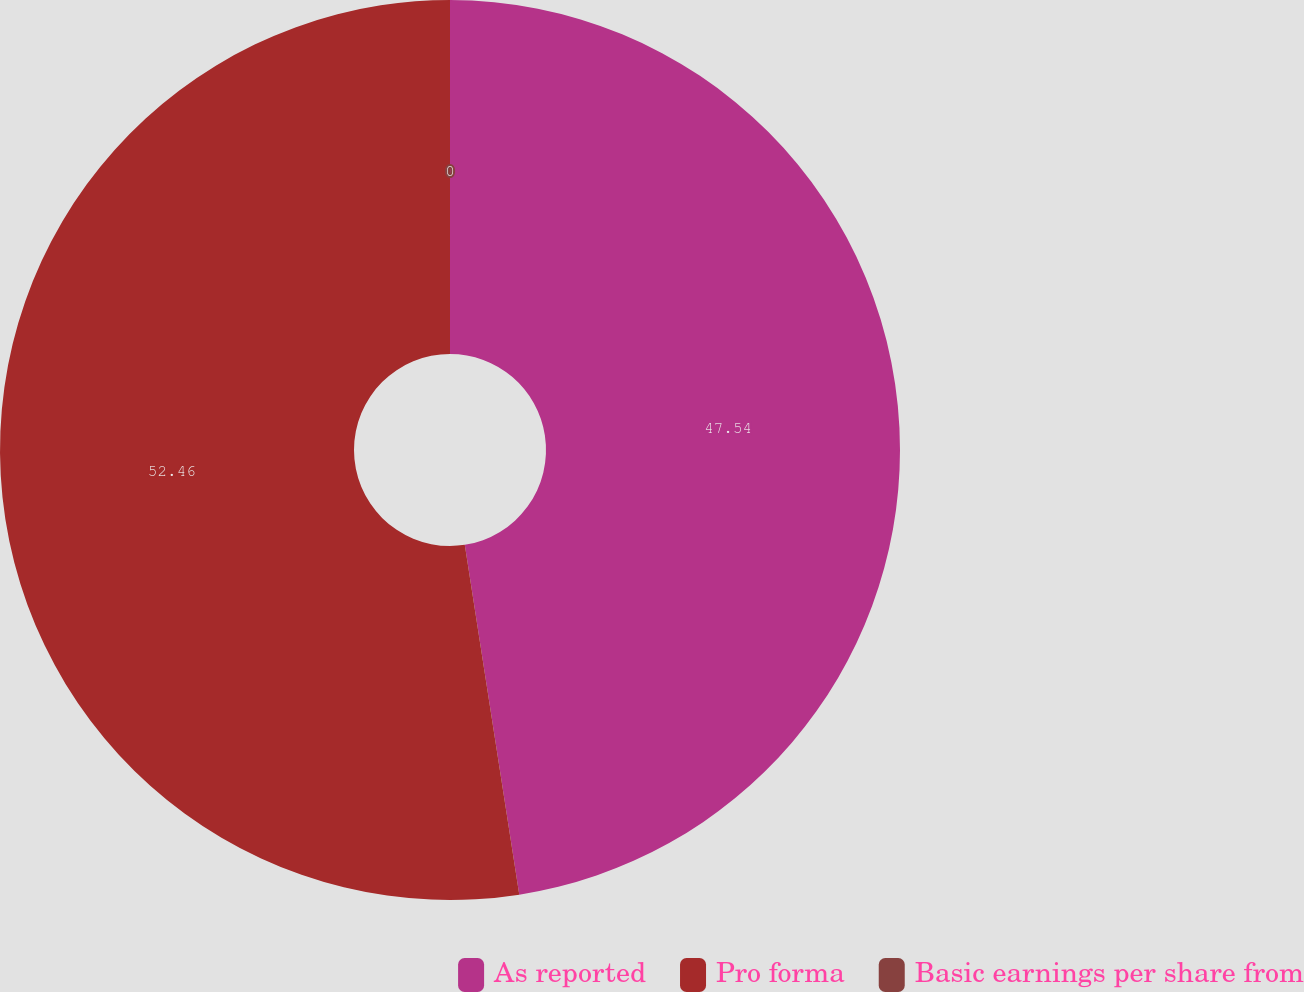Convert chart to OTSL. <chart><loc_0><loc_0><loc_500><loc_500><pie_chart><fcel>As reported<fcel>Pro forma<fcel>Basic earnings per share from<nl><fcel>47.54%<fcel>52.46%<fcel>0.0%<nl></chart> 